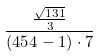Convert formula to latex. <formula><loc_0><loc_0><loc_500><loc_500>\frac { \frac { \sqrt { 1 3 1 } } { 3 } } { ( 4 5 4 - 1 ) \cdot 7 }</formula> 